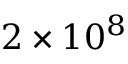<formula> <loc_0><loc_0><loc_500><loc_500>2 \times 1 0 ^ { 8 }</formula> 